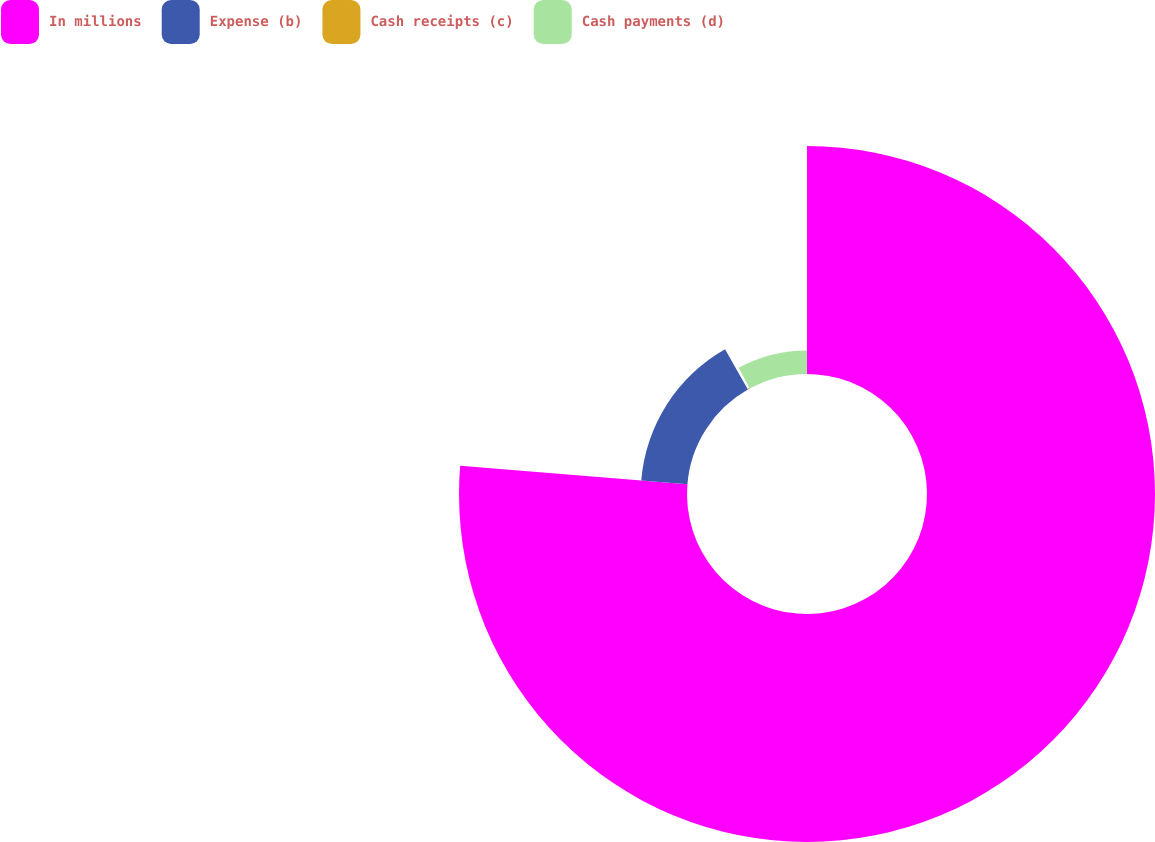Convert chart. <chart><loc_0><loc_0><loc_500><loc_500><pie_chart><fcel>In millions<fcel>Expense (b)<fcel>Cash receipts (c)<fcel>Cash payments (d)<nl><fcel>76.29%<fcel>15.5%<fcel>0.3%<fcel>7.9%<nl></chart> 